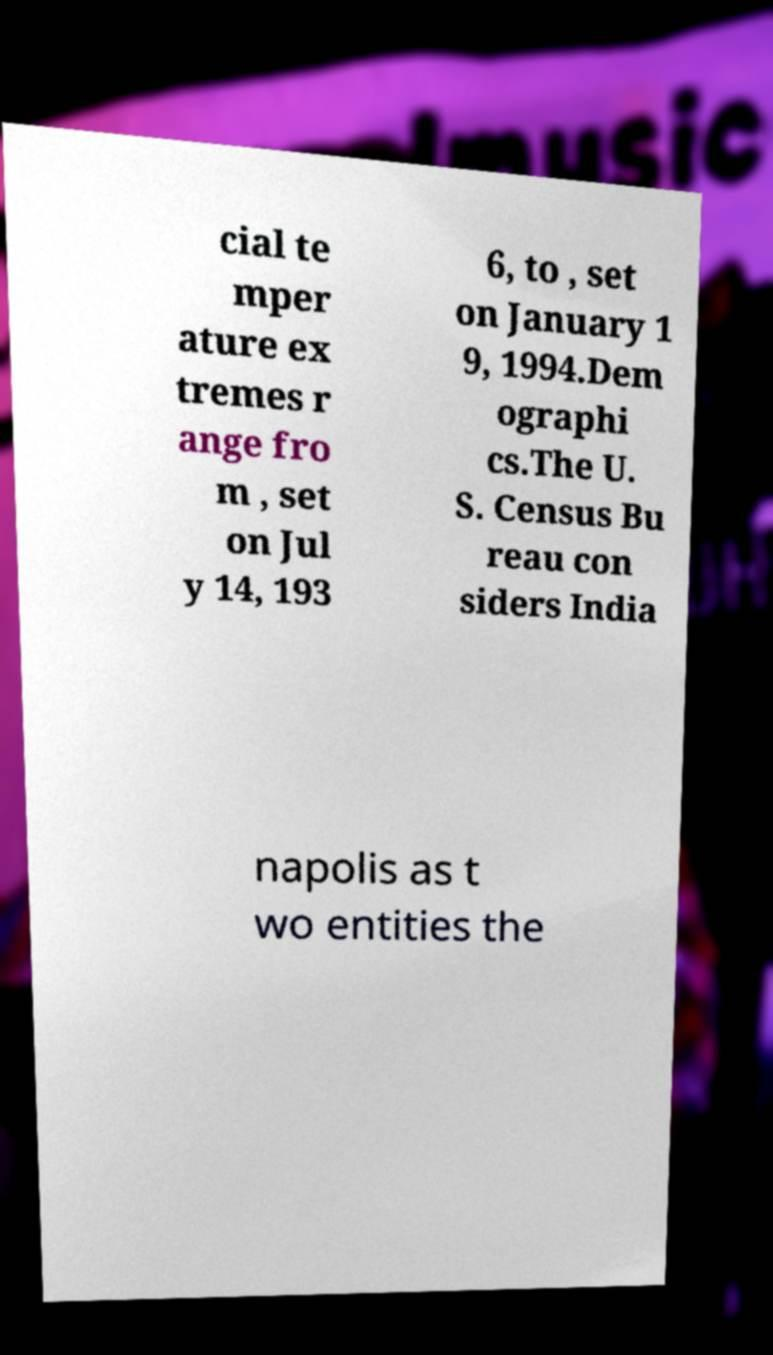What messages or text are displayed in this image? I need them in a readable, typed format. cial te mper ature ex tremes r ange fro m , set on Jul y 14, 193 6, to , set on January 1 9, 1994.Dem ographi cs.The U. S. Census Bu reau con siders India napolis as t wo entities the 